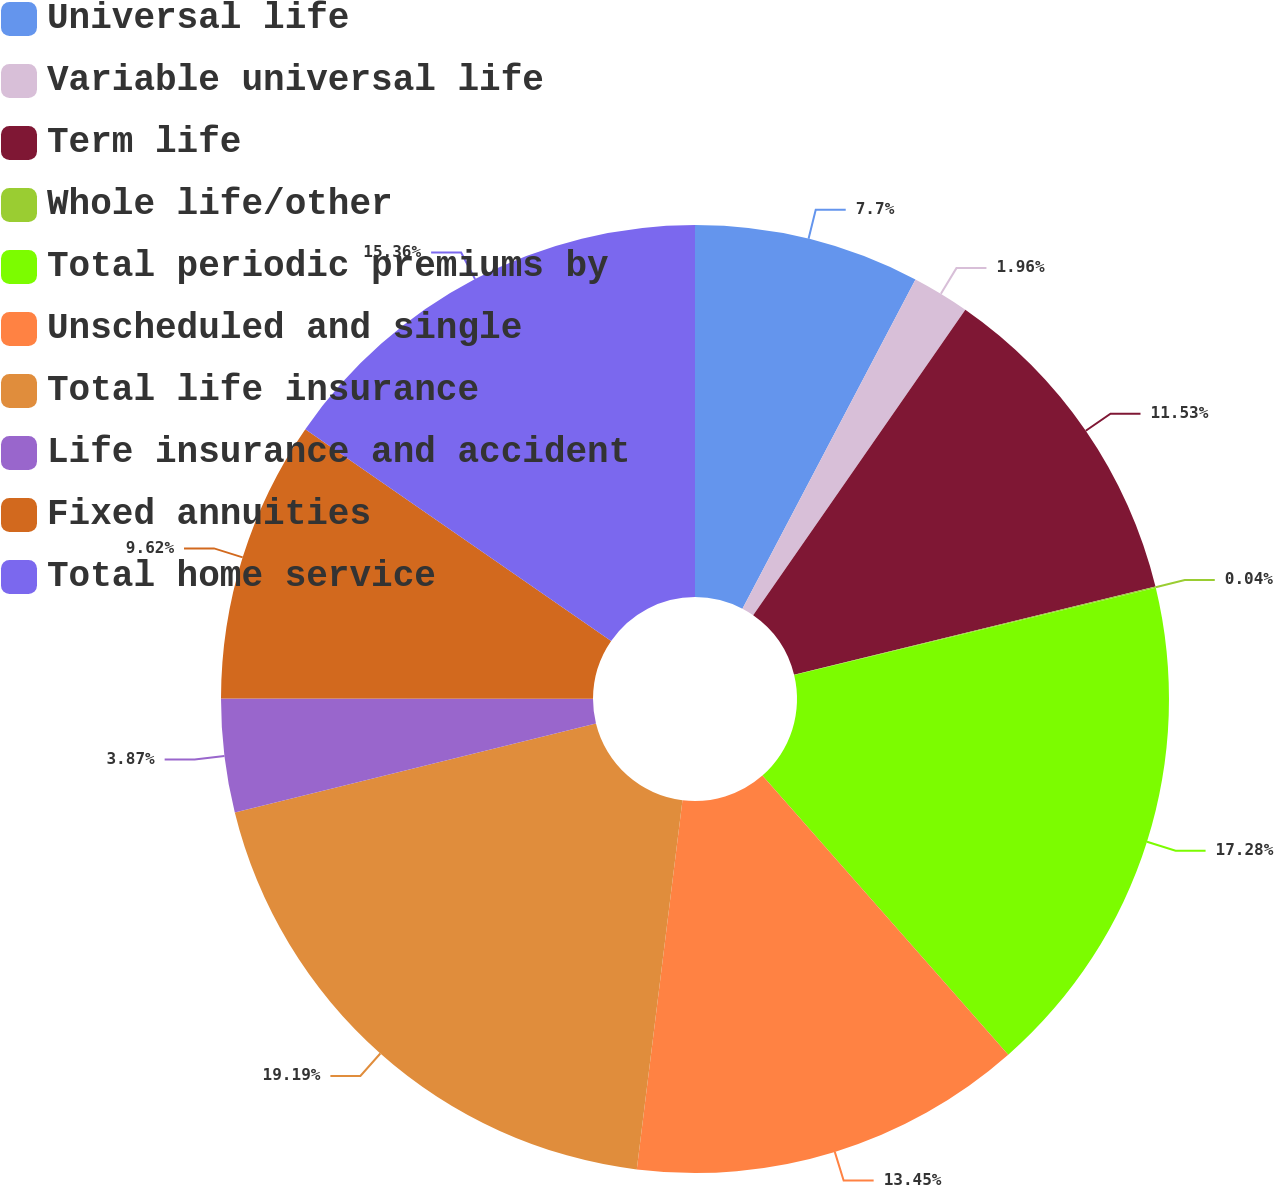<chart> <loc_0><loc_0><loc_500><loc_500><pie_chart><fcel>Universal life<fcel>Variable universal life<fcel>Term life<fcel>Whole life/other<fcel>Total periodic premiums by<fcel>Unscheduled and single<fcel>Total life insurance<fcel>Life insurance and accident<fcel>Fixed annuities<fcel>Total home service<nl><fcel>7.7%<fcel>1.96%<fcel>11.53%<fcel>0.04%<fcel>17.28%<fcel>13.45%<fcel>19.19%<fcel>3.87%<fcel>9.62%<fcel>15.36%<nl></chart> 